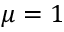Convert formula to latex. <formula><loc_0><loc_0><loc_500><loc_500>\mu = 1</formula> 